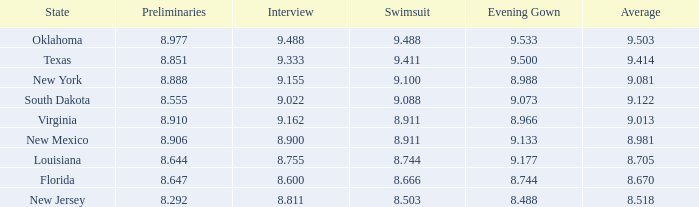What's the evening dress where the state is south dakota? 9.073. 